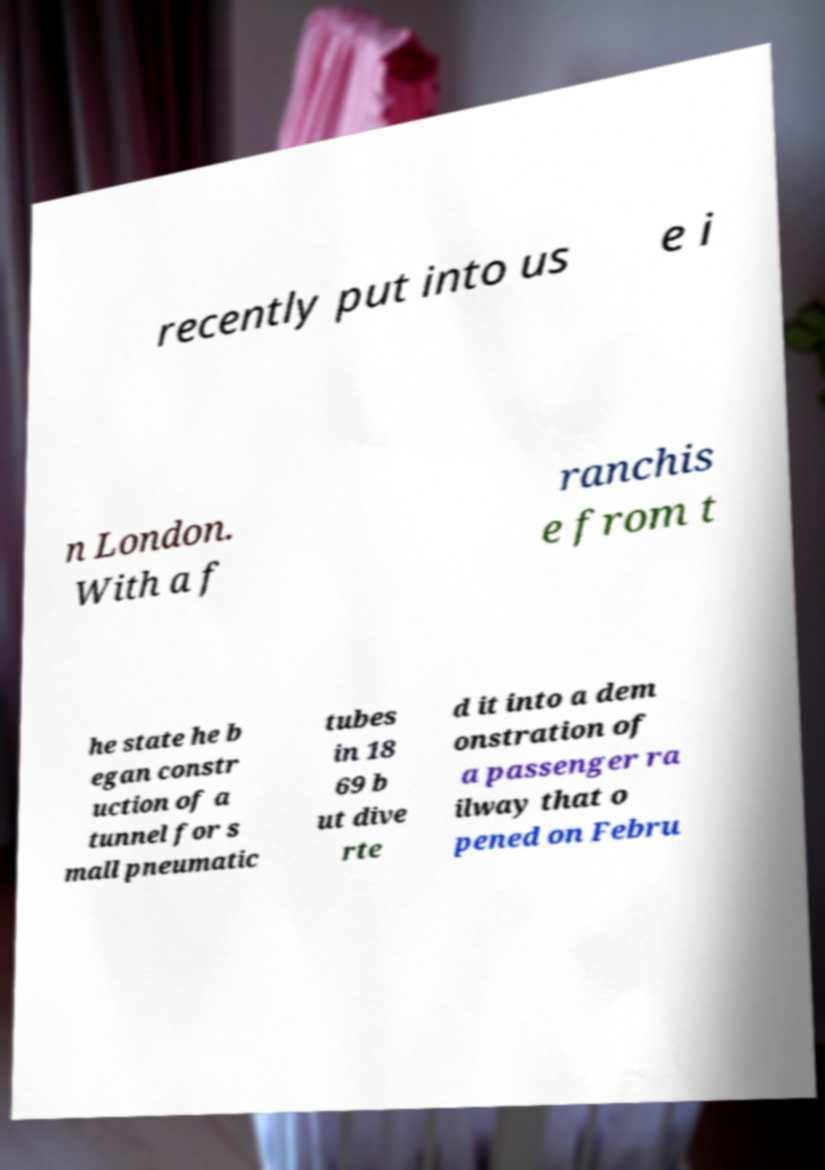Please identify and transcribe the text found in this image. recently put into us e i n London. With a f ranchis e from t he state he b egan constr uction of a tunnel for s mall pneumatic tubes in 18 69 b ut dive rte d it into a dem onstration of a passenger ra ilway that o pened on Febru 